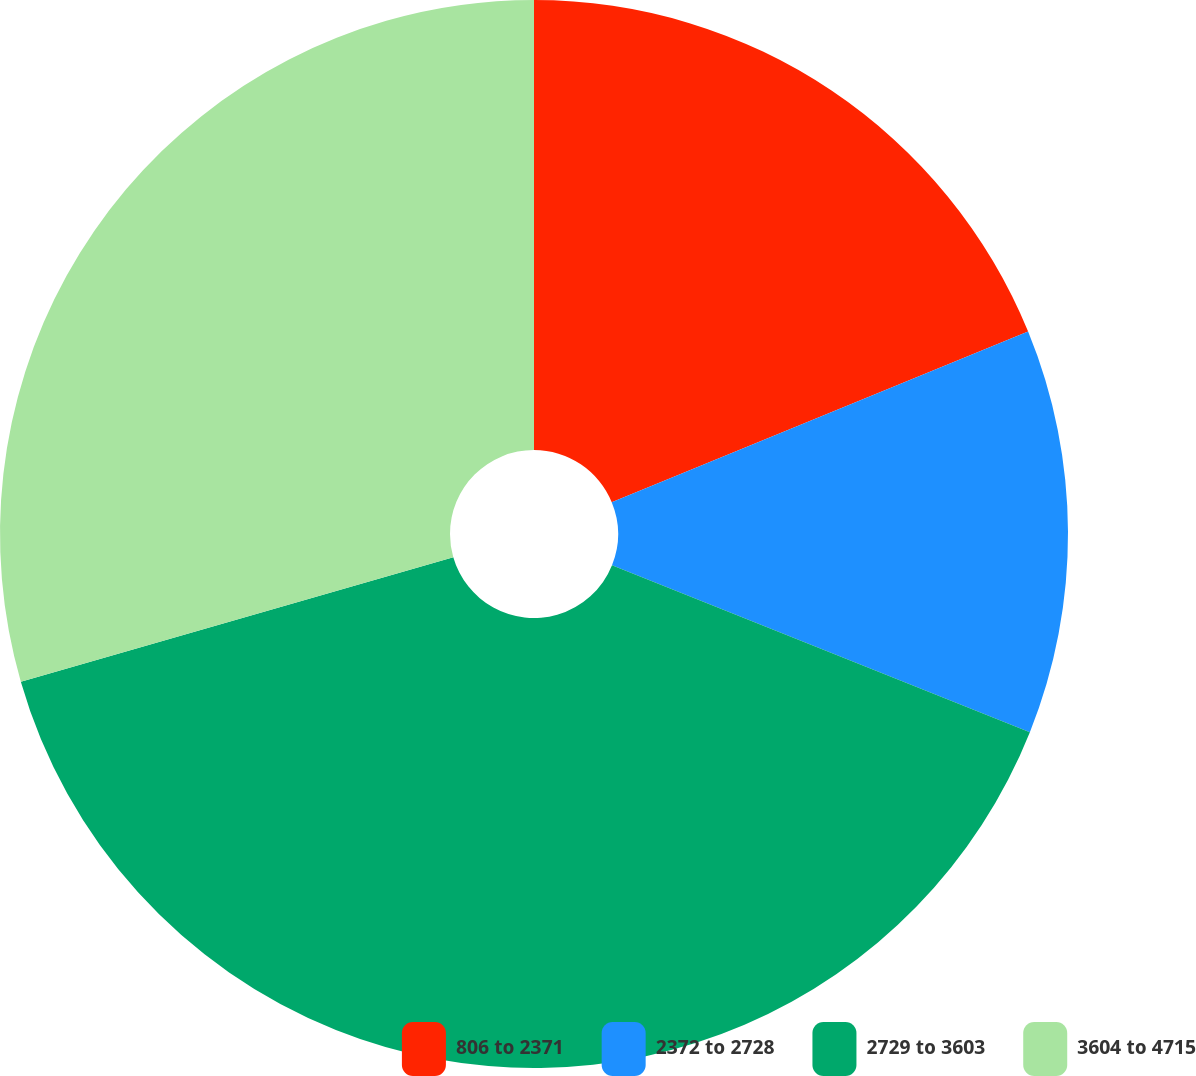<chart> <loc_0><loc_0><loc_500><loc_500><pie_chart><fcel>806 to 2371<fcel>2372 to 2728<fcel>2729 to 3603<fcel>3604 to 4715<nl><fcel>18.81%<fcel>12.24%<fcel>39.49%<fcel>29.46%<nl></chart> 